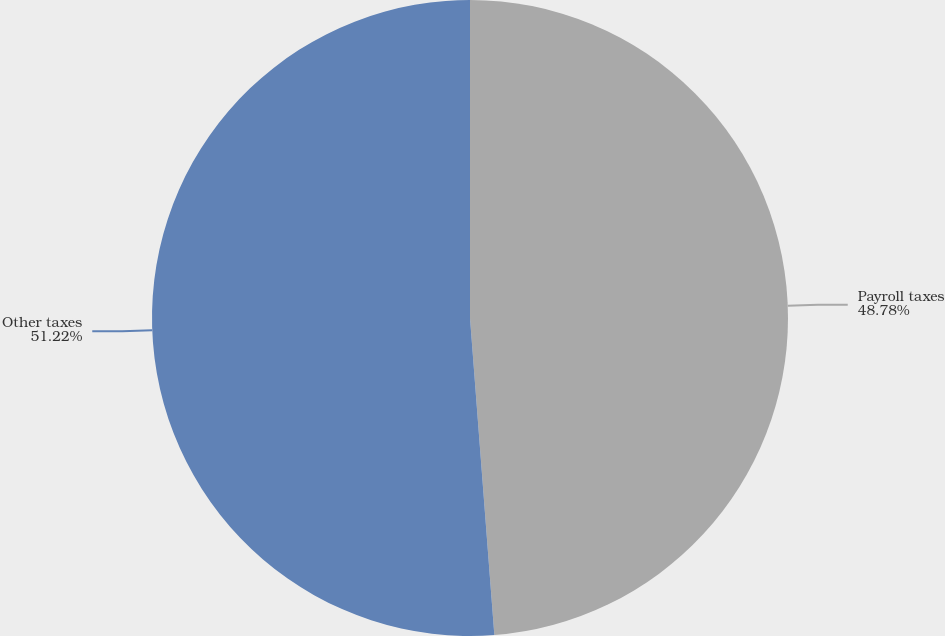Convert chart. <chart><loc_0><loc_0><loc_500><loc_500><pie_chart><fcel>Payroll taxes<fcel>Other taxes<nl><fcel>48.78%<fcel>51.22%<nl></chart> 